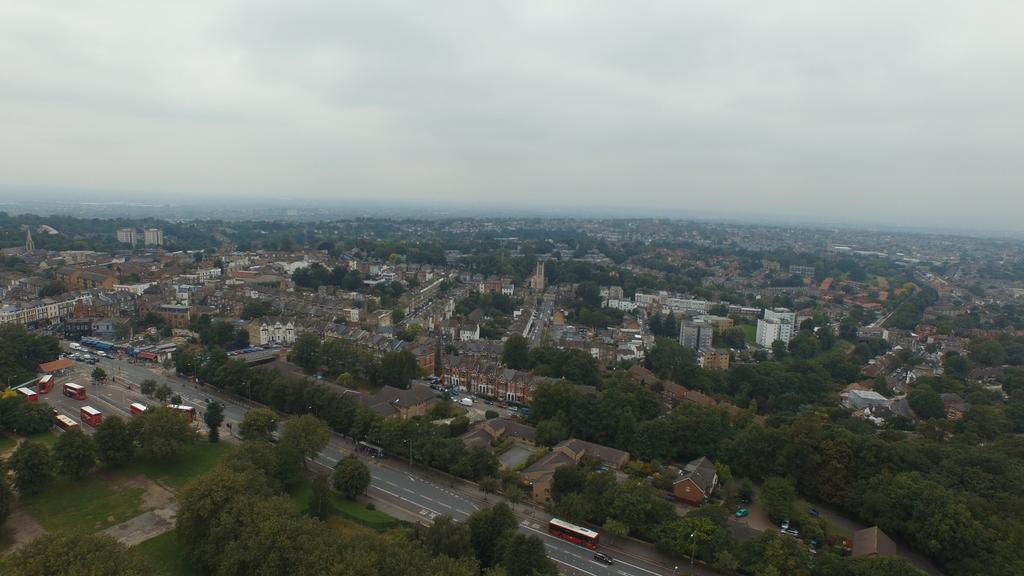In one or two sentences, can you explain what this image depicts? This is the aerial view where we can see some vehicles which are moving on road and there are some trees, we can see some buildings and top of the picture there is cloudy sky. 